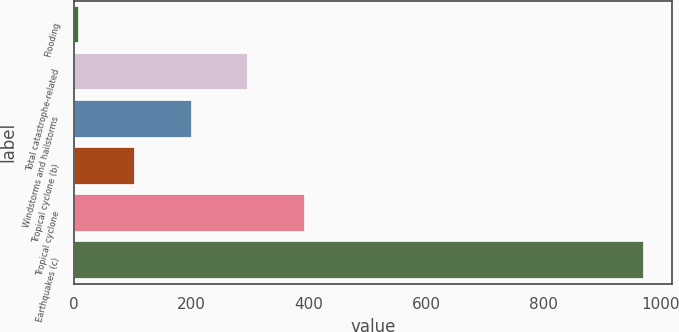Convert chart to OTSL. <chart><loc_0><loc_0><loc_500><loc_500><bar_chart><fcel>Flooding<fcel>Total catastrophe-related<fcel>Windstorms and hailstorms<fcel>Tropical cyclone (b)<fcel>Tropical cyclone<fcel>Earthquakes (c)<nl><fcel>8<fcel>296.9<fcel>200.6<fcel>104.3<fcel>393.2<fcel>971<nl></chart> 